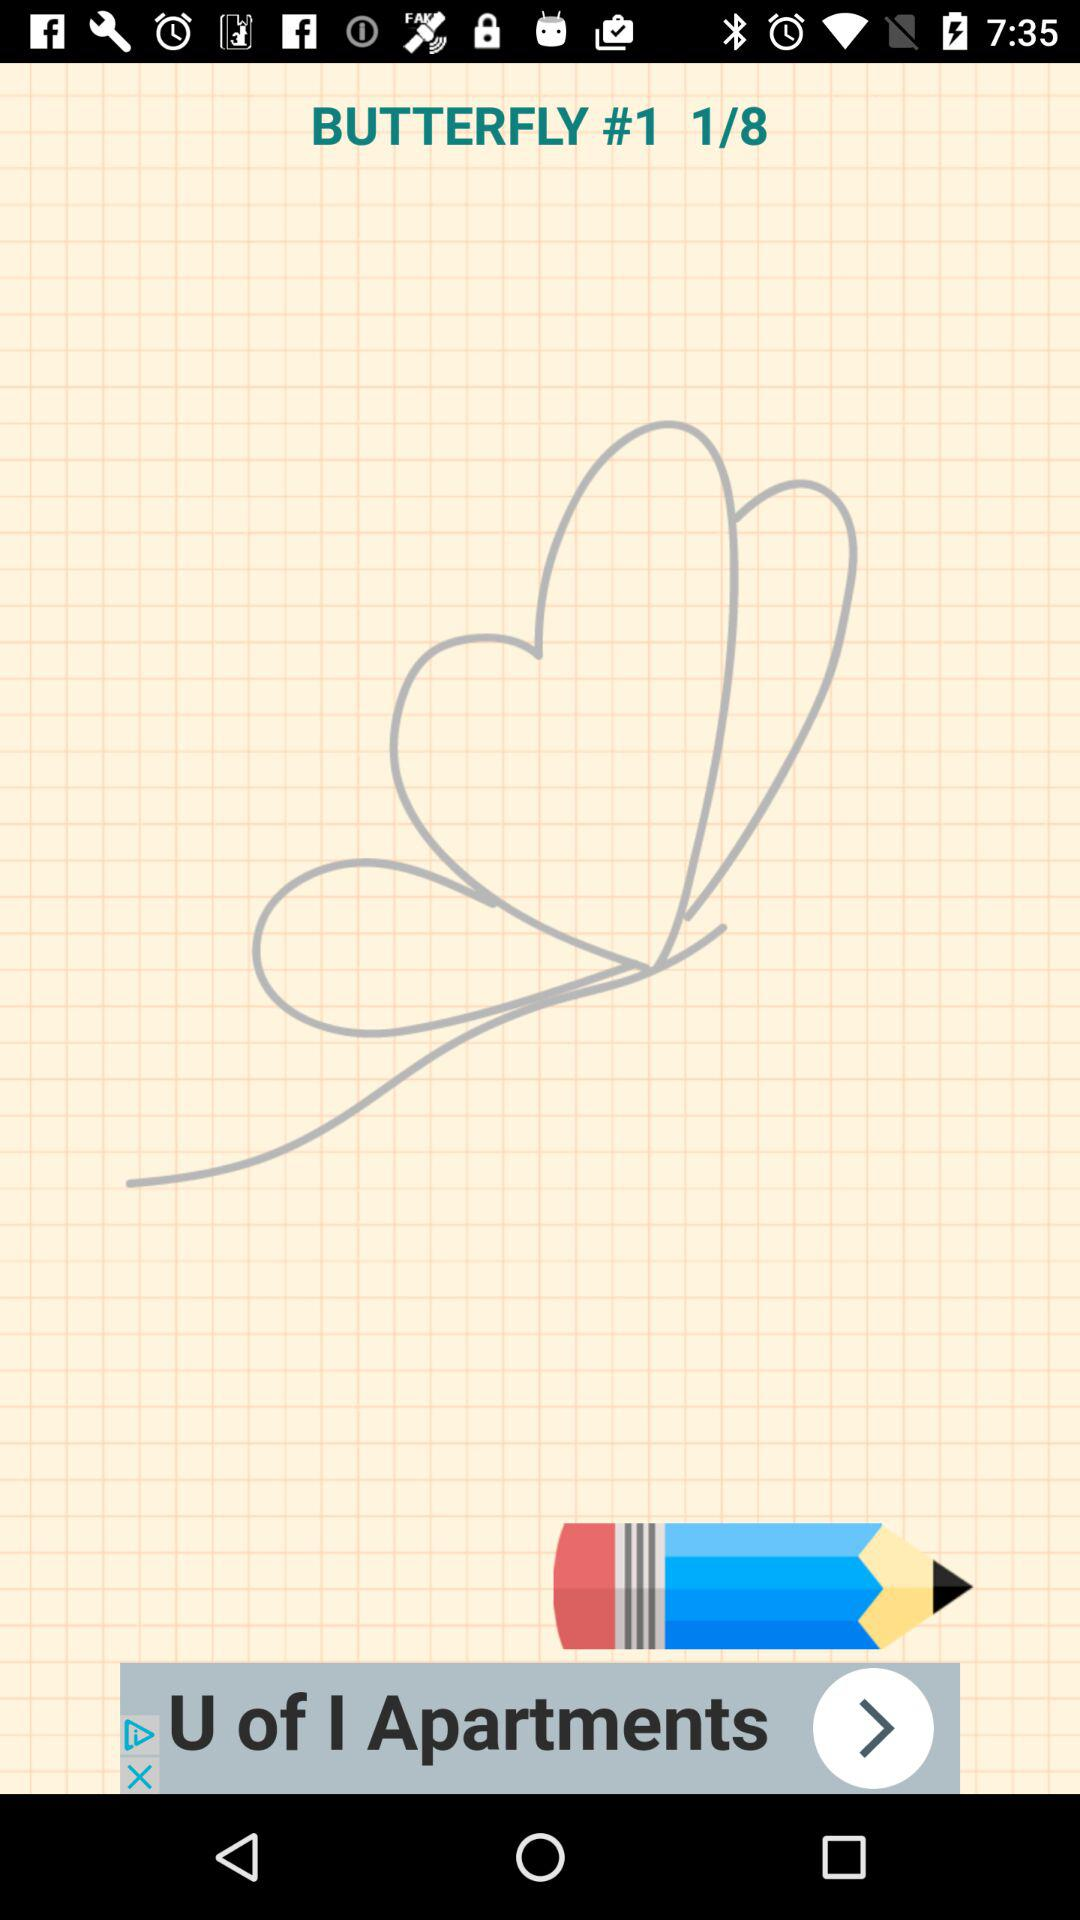How many steps are there in total? There are 8 steps in total. 